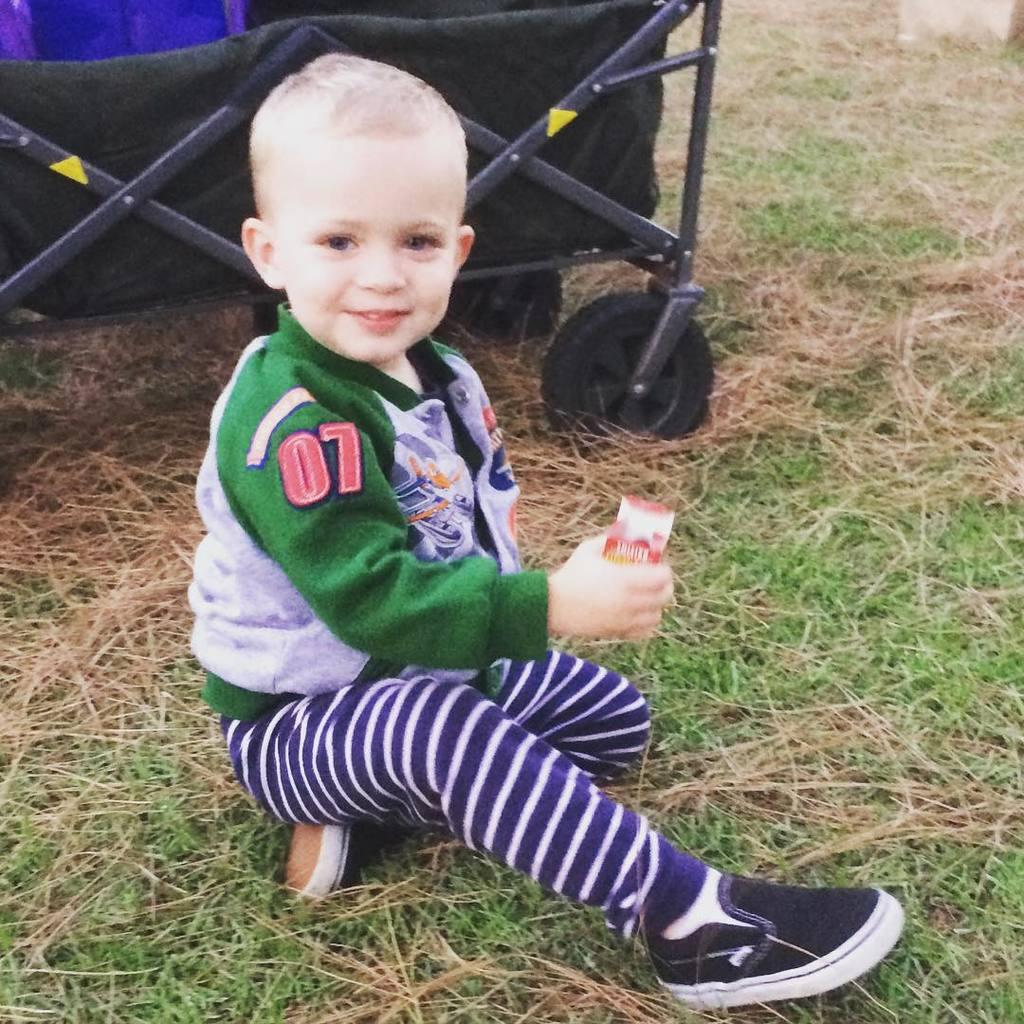Who or what is present in the image? There is a person in the image. What is the person wearing? The person is wearing a dress with blue, white, and green colors. Where is the person sitting? The person is sitting on the grass. What can be seen in the background of the image? There is a black color trolley in the background of the image. What type of line is being used to create motion in the image? There is no line or motion present in the image; it is a still image of a person sitting on the grass. Can you see a bottle in the image? There is no bottle present in the image. 